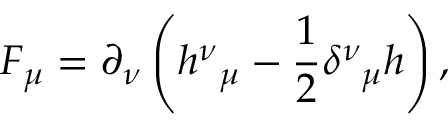<formula> <loc_0><loc_0><loc_500><loc_500>F _ { \mu } = \partial _ { \nu } \left ( h _ { \, \mu } ^ { \nu } - \frac { 1 } { 2 } \delta _ { \, \mu } ^ { \nu } h \right ) ,</formula> 